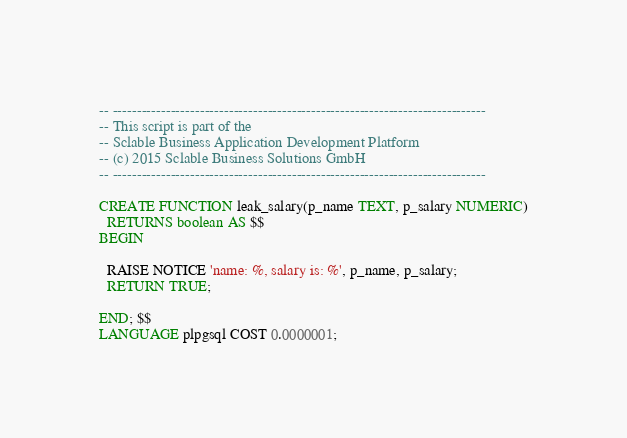<code> <loc_0><loc_0><loc_500><loc_500><_SQL_>-- -----------------------------------------------------------------------------
-- This script is part of the 
-- Sclable Business Application Development Platform
-- (c) 2015 Sclable Business Solutions GmbH
-- -----------------------------------------------------------------------------

CREATE FUNCTION leak_salary(p_name TEXT, p_salary NUMERIC)
  RETURNS boolean AS $$
BEGIN

  RAISE NOTICE 'name: %, salary is: %', p_name, p_salary;
  RETURN TRUE;

END; $$
LANGUAGE plpgsql COST 0.0000001;</code> 